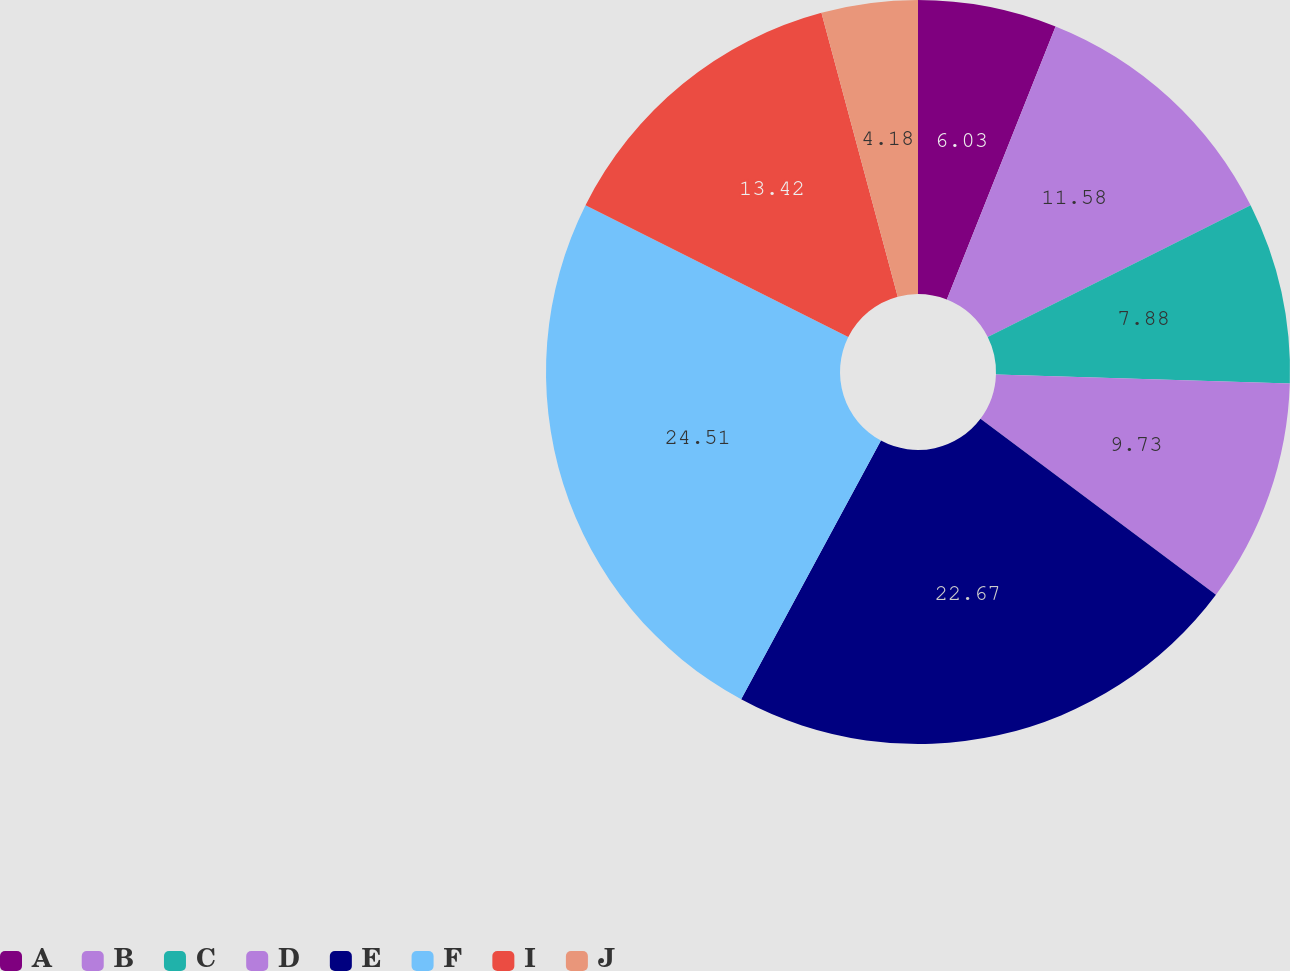Convert chart to OTSL. <chart><loc_0><loc_0><loc_500><loc_500><pie_chart><fcel>A<fcel>B<fcel>C<fcel>D<fcel>E<fcel>F<fcel>I<fcel>J<nl><fcel>6.03%<fcel>11.58%<fcel>7.88%<fcel>9.73%<fcel>22.67%<fcel>24.52%<fcel>13.42%<fcel>4.18%<nl></chart> 